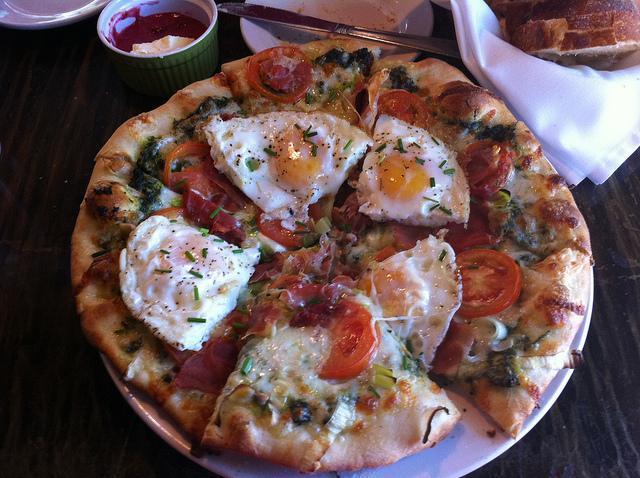How many slices is this cut into?
Give a very brief answer. 6. How many pizzas are there?
Give a very brief answer. 1. 